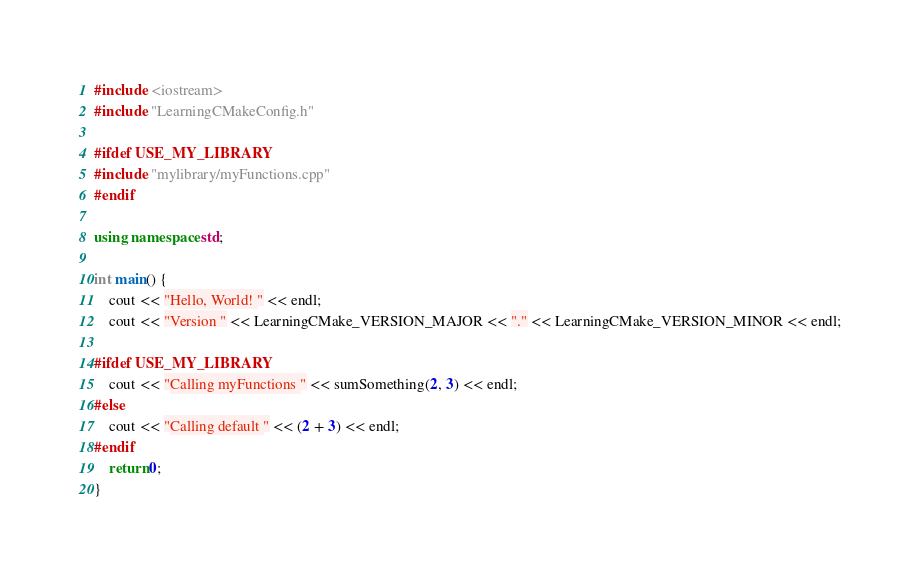<code> <loc_0><loc_0><loc_500><loc_500><_C++_>#include <iostream>
#include "LearningCMakeConfig.h"

#ifdef USE_MY_LIBRARY
#include "mylibrary/myFunctions.cpp"
#endif

using namespace std;

int main() {
    cout << "Hello, World! " << endl;
    cout << "Version " << LearningCMake_VERSION_MAJOR << "." << LearningCMake_VERSION_MINOR << endl;

#ifdef USE_MY_LIBRARY
    cout << "Calling myFunctions " << sumSomething(2, 3) << endl;
#else
    cout << "Calling default " << (2 + 3) << endl;
#endif
    return 0;
}</code> 